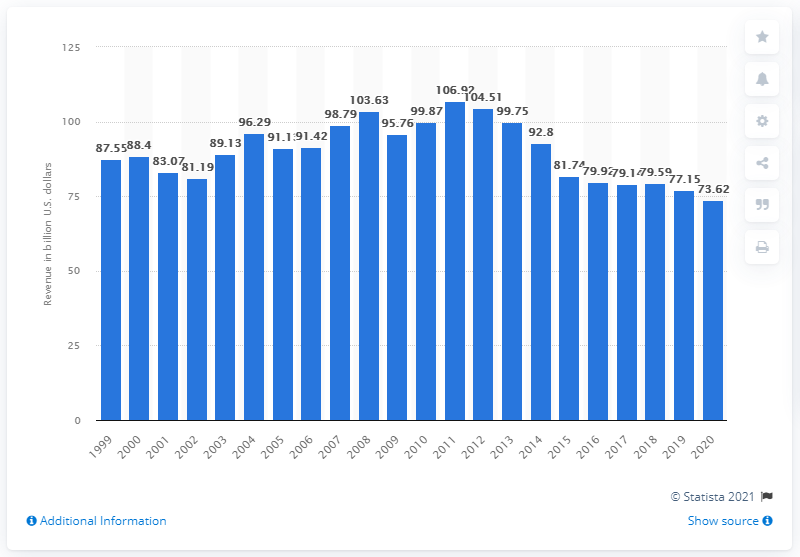Specify some key components in this picture. In 2011, IBM's revenue was approximately 106.92 billion dollars. In 2020, IBM's revenue was 73.62. 